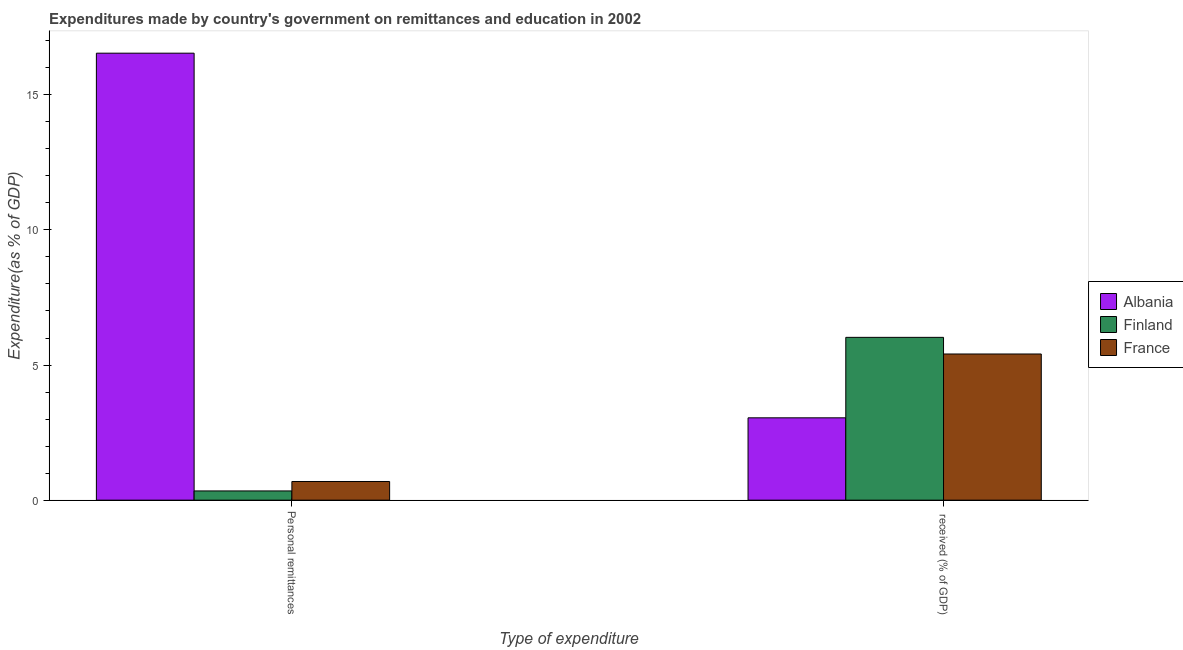How many different coloured bars are there?
Make the answer very short. 3. How many bars are there on the 2nd tick from the left?
Give a very brief answer. 3. What is the label of the 2nd group of bars from the left?
Keep it short and to the point.  received (% of GDP). What is the expenditure in education in Finland?
Make the answer very short. 6.02. Across all countries, what is the maximum expenditure in personal remittances?
Keep it short and to the point. 16.54. Across all countries, what is the minimum expenditure in personal remittances?
Offer a terse response. 0.34. In which country was the expenditure in education minimum?
Your response must be concise. Albania. What is the total expenditure in personal remittances in the graph?
Offer a very short reply. 17.57. What is the difference between the expenditure in personal remittances in Finland and that in France?
Give a very brief answer. -0.35. What is the difference between the expenditure in personal remittances in Albania and the expenditure in education in Finland?
Make the answer very short. 10.52. What is the average expenditure in education per country?
Give a very brief answer. 4.83. What is the difference between the expenditure in education and expenditure in personal remittances in Albania?
Give a very brief answer. -13.49. What is the ratio of the expenditure in education in Albania to that in France?
Make the answer very short. 0.56. In how many countries, is the expenditure in education greater than the average expenditure in education taken over all countries?
Give a very brief answer. 2. What does the 1st bar from the left in  received (% of GDP) represents?
Ensure brevity in your answer.  Albania. What does the 1st bar from the right in Personal remittances represents?
Ensure brevity in your answer.  France. How many bars are there?
Ensure brevity in your answer.  6. Are the values on the major ticks of Y-axis written in scientific E-notation?
Provide a short and direct response. No. How are the legend labels stacked?
Offer a terse response. Vertical. What is the title of the graph?
Offer a terse response. Expenditures made by country's government on remittances and education in 2002. What is the label or title of the X-axis?
Offer a terse response. Type of expenditure. What is the label or title of the Y-axis?
Provide a succinct answer. Expenditure(as % of GDP). What is the Expenditure(as % of GDP) in Albania in Personal remittances?
Your answer should be compact. 16.54. What is the Expenditure(as % of GDP) in Finland in Personal remittances?
Your answer should be very brief. 0.34. What is the Expenditure(as % of GDP) in France in Personal remittances?
Make the answer very short. 0.69. What is the Expenditure(as % of GDP) in Albania in  received (% of GDP)?
Offer a terse response. 3.05. What is the Expenditure(as % of GDP) of Finland in  received (% of GDP)?
Give a very brief answer. 6.02. What is the Expenditure(as % of GDP) of France in  received (% of GDP)?
Provide a succinct answer. 5.41. Across all Type of expenditure, what is the maximum Expenditure(as % of GDP) of Albania?
Give a very brief answer. 16.54. Across all Type of expenditure, what is the maximum Expenditure(as % of GDP) in Finland?
Give a very brief answer. 6.02. Across all Type of expenditure, what is the maximum Expenditure(as % of GDP) in France?
Your answer should be compact. 5.41. Across all Type of expenditure, what is the minimum Expenditure(as % of GDP) in Albania?
Give a very brief answer. 3.05. Across all Type of expenditure, what is the minimum Expenditure(as % of GDP) of Finland?
Provide a short and direct response. 0.34. Across all Type of expenditure, what is the minimum Expenditure(as % of GDP) in France?
Offer a terse response. 0.69. What is the total Expenditure(as % of GDP) in Albania in the graph?
Your answer should be very brief. 19.59. What is the total Expenditure(as % of GDP) in Finland in the graph?
Your answer should be very brief. 6.37. What is the total Expenditure(as % of GDP) of France in the graph?
Make the answer very short. 6.1. What is the difference between the Expenditure(as % of GDP) of Albania in Personal remittances and that in  received (% of GDP)?
Offer a very short reply. 13.49. What is the difference between the Expenditure(as % of GDP) in Finland in Personal remittances and that in  received (% of GDP)?
Keep it short and to the point. -5.68. What is the difference between the Expenditure(as % of GDP) in France in Personal remittances and that in  received (% of GDP)?
Give a very brief answer. -4.72. What is the difference between the Expenditure(as % of GDP) in Albania in Personal remittances and the Expenditure(as % of GDP) in Finland in  received (% of GDP)?
Your answer should be compact. 10.52. What is the difference between the Expenditure(as % of GDP) of Albania in Personal remittances and the Expenditure(as % of GDP) of France in  received (% of GDP)?
Your answer should be very brief. 11.13. What is the difference between the Expenditure(as % of GDP) in Finland in Personal remittances and the Expenditure(as % of GDP) in France in  received (% of GDP)?
Make the answer very short. -5.07. What is the average Expenditure(as % of GDP) in Albania per Type of expenditure?
Your answer should be very brief. 9.79. What is the average Expenditure(as % of GDP) of Finland per Type of expenditure?
Your response must be concise. 3.18. What is the average Expenditure(as % of GDP) of France per Type of expenditure?
Your answer should be compact. 3.05. What is the difference between the Expenditure(as % of GDP) in Albania and Expenditure(as % of GDP) in Finland in Personal remittances?
Provide a succinct answer. 16.2. What is the difference between the Expenditure(as % of GDP) in Albania and Expenditure(as % of GDP) in France in Personal remittances?
Keep it short and to the point. 15.85. What is the difference between the Expenditure(as % of GDP) of Finland and Expenditure(as % of GDP) of France in Personal remittances?
Make the answer very short. -0.35. What is the difference between the Expenditure(as % of GDP) in Albania and Expenditure(as % of GDP) in Finland in  received (% of GDP)?
Your answer should be compact. -2.98. What is the difference between the Expenditure(as % of GDP) in Albania and Expenditure(as % of GDP) in France in  received (% of GDP)?
Ensure brevity in your answer.  -2.36. What is the difference between the Expenditure(as % of GDP) in Finland and Expenditure(as % of GDP) in France in  received (% of GDP)?
Provide a short and direct response. 0.62. What is the ratio of the Expenditure(as % of GDP) of Albania in Personal remittances to that in  received (% of GDP)?
Your answer should be compact. 5.43. What is the ratio of the Expenditure(as % of GDP) of Finland in Personal remittances to that in  received (% of GDP)?
Provide a succinct answer. 0.06. What is the ratio of the Expenditure(as % of GDP) in France in Personal remittances to that in  received (% of GDP)?
Ensure brevity in your answer.  0.13. What is the difference between the highest and the second highest Expenditure(as % of GDP) in Albania?
Offer a very short reply. 13.49. What is the difference between the highest and the second highest Expenditure(as % of GDP) in Finland?
Your answer should be very brief. 5.68. What is the difference between the highest and the second highest Expenditure(as % of GDP) of France?
Offer a very short reply. 4.72. What is the difference between the highest and the lowest Expenditure(as % of GDP) of Albania?
Make the answer very short. 13.49. What is the difference between the highest and the lowest Expenditure(as % of GDP) in Finland?
Your answer should be compact. 5.68. What is the difference between the highest and the lowest Expenditure(as % of GDP) of France?
Offer a terse response. 4.72. 